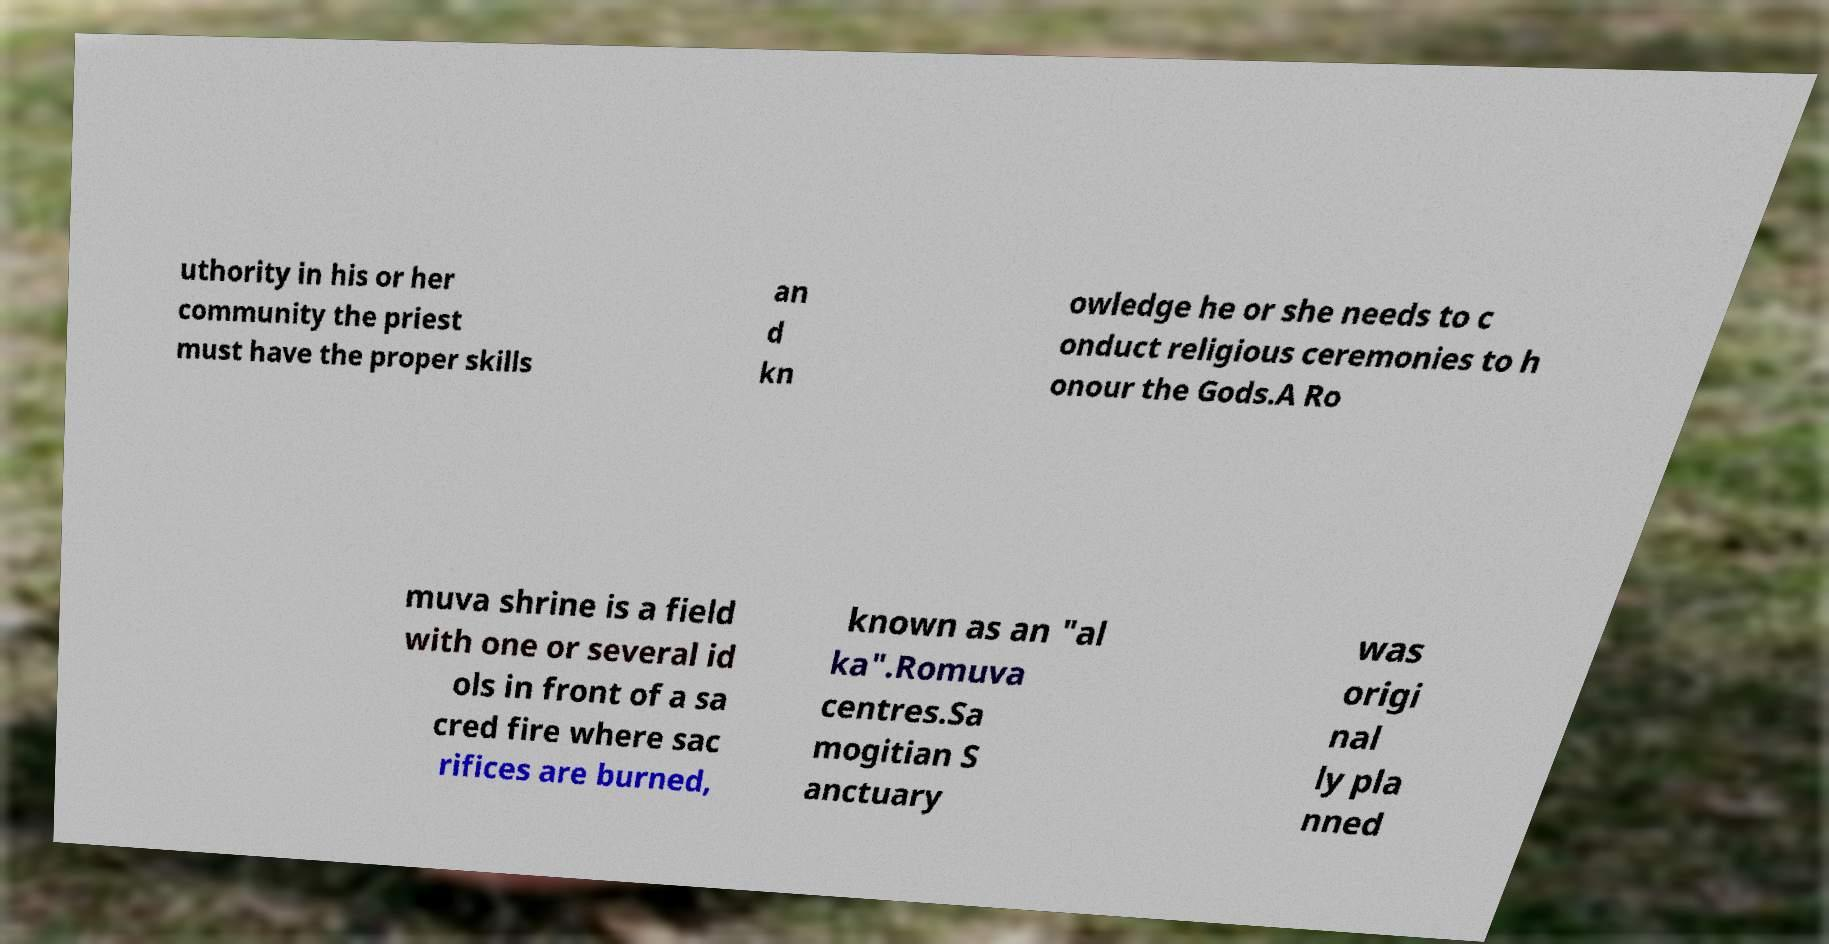Could you assist in decoding the text presented in this image and type it out clearly? uthority in his or her community the priest must have the proper skills an d kn owledge he or she needs to c onduct religious ceremonies to h onour the Gods.A Ro muva shrine is a field with one or several id ols in front of a sa cred fire where sac rifices are burned, known as an "al ka".Romuva centres.Sa mogitian S anctuary was origi nal ly pla nned 